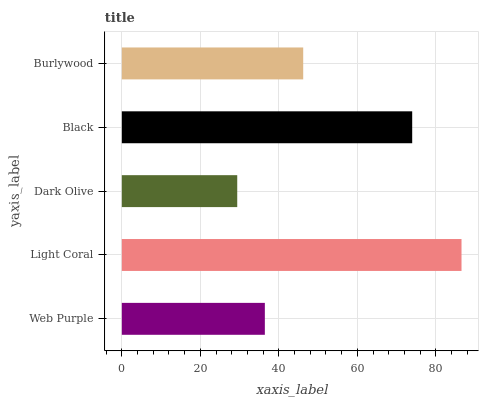Is Dark Olive the minimum?
Answer yes or no. Yes. Is Light Coral the maximum?
Answer yes or no. Yes. Is Light Coral the minimum?
Answer yes or no. No. Is Dark Olive the maximum?
Answer yes or no. No. Is Light Coral greater than Dark Olive?
Answer yes or no. Yes. Is Dark Olive less than Light Coral?
Answer yes or no. Yes. Is Dark Olive greater than Light Coral?
Answer yes or no. No. Is Light Coral less than Dark Olive?
Answer yes or no. No. Is Burlywood the high median?
Answer yes or no. Yes. Is Burlywood the low median?
Answer yes or no. Yes. Is Dark Olive the high median?
Answer yes or no. No. Is Dark Olive the low median?
Answer yes or no. No. 